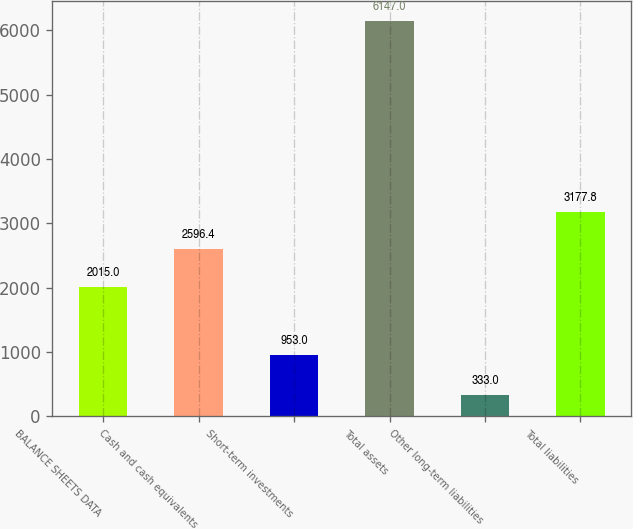<chart> <loc_0><loc_0><loc_500><loc_500><bar_chart><fcel>BALANCE SHEETS DATA<fcel>Cash and cash equivalents<fcel>Short-term investments<fcel>Total assets<fcel>Other long-term liabilities<fcel>Total liabilities<nl><fcel>2015<fcel>2596.4<fcel>953<fcel>6147<fcel>333<fcel>3177.8<nl></chart> 